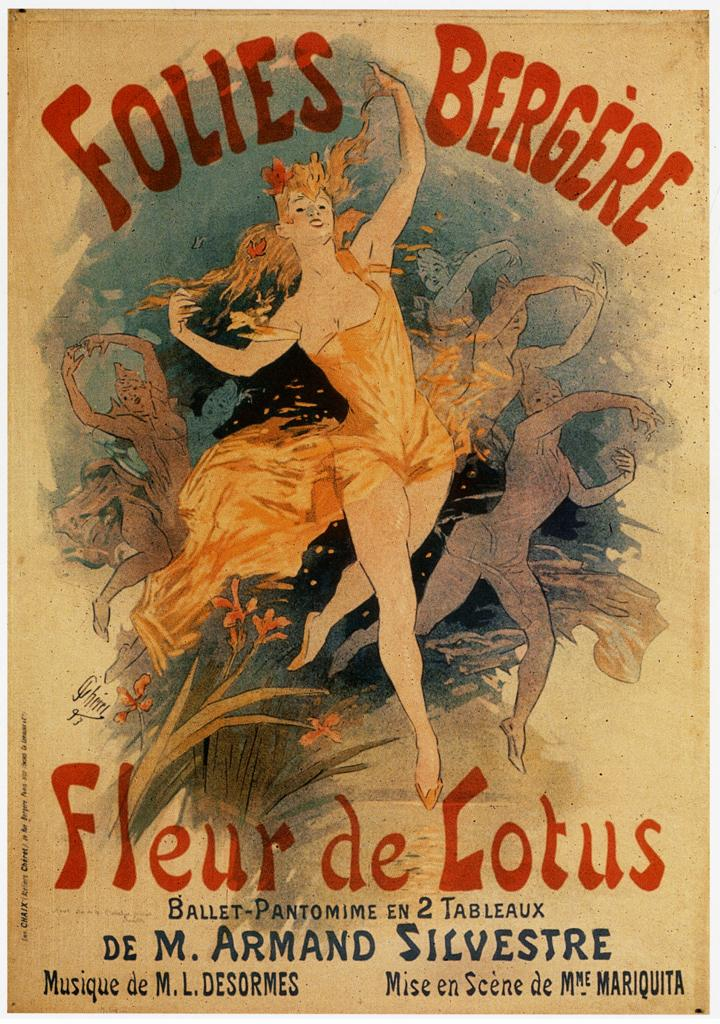<image>
Share a concise interpretation of the image provided. A poster for the Follies Bergere advertises Fleur de Lotus. 